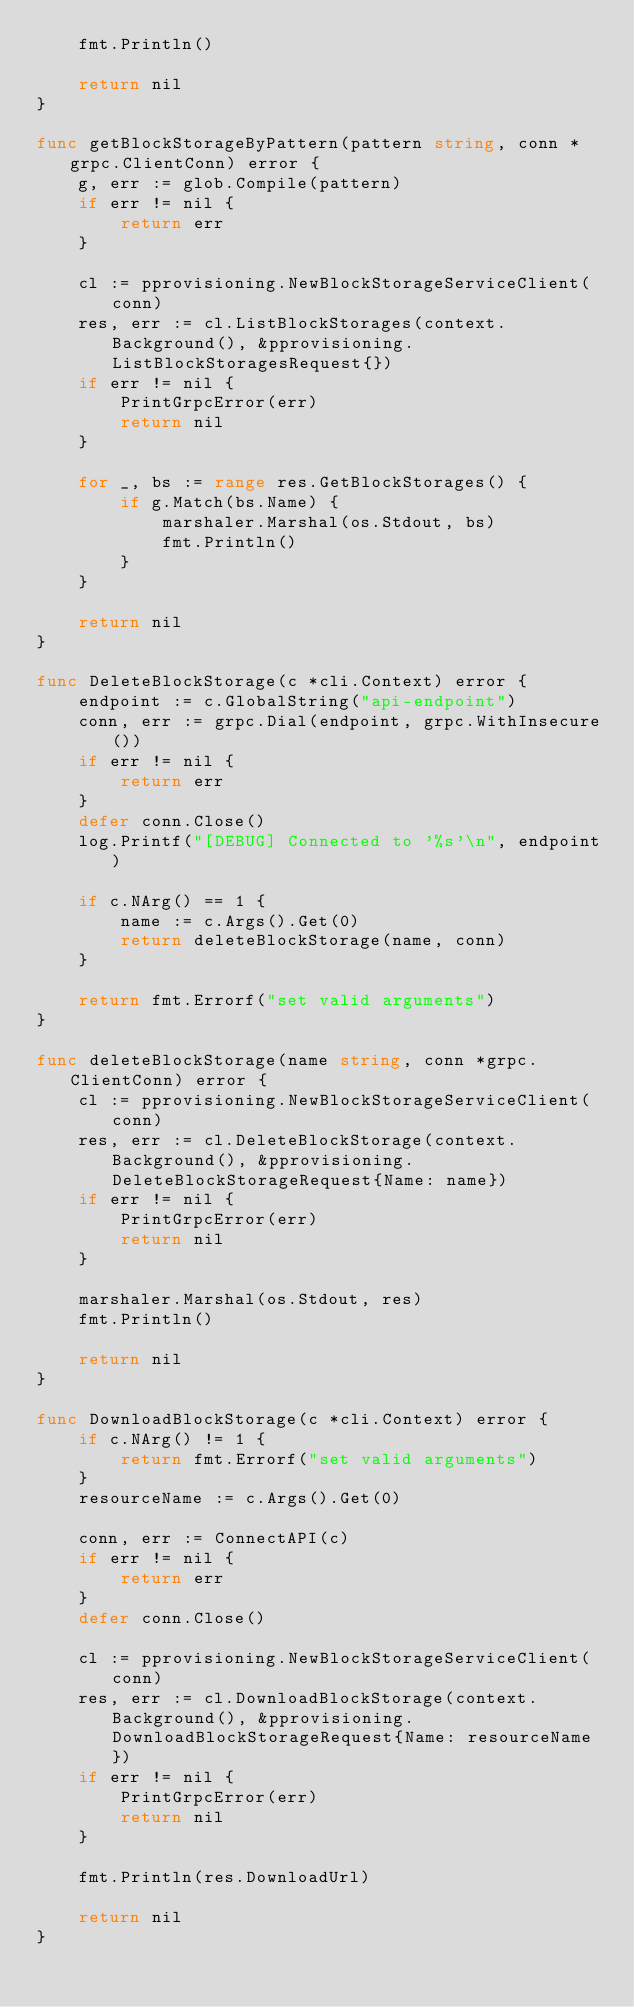<code> <loc_0><loc_0><loc_500><loc_500><_Go_>	fmt.Println()

	return nil
}

func getBlockStorageByPattern(pattern string, conn *grpc.ClientConn) error {
	g, err := glob.Compile(pattern)
	if err != nil {
		return err
	}

	cl := pprovisioning.NewBlockStorageServiceClient(conn)
	res, err := cl.ListBlockStorages(context.Background(), &pprovisioning.ListBlockStoragesRequest{})
	if err != nil {
		PrintGrpcError(err)
		return nil
	}

	for _, bs := range res.GetBlockStorages() {
		if g.Match(bs.Name) {
			marshaler.Marshal(os.Stdout, bs)
			fmt.Println()
		}
	}

	return nil
}

func DeleteBlockStorage(c *cli.Context) error {
	endpoint := c.GlobalString("api-endpoint")
	conn, err := grpc.Dial(endpoint, grpc.WithInsecure())
	if err != nil {
		return err
	}
	defer conn.Close()
	log.Printf("[DEBUG] Connected to '%s'\n", endpoint)

	if c.NArg() == 1 {
		name := c.Args().Get(0)
		return deleteBlockStorage(name, conn)
	}

	return fmt.Errorf("set valid arguments")
}

func deleteBlockStorage(name string, conn *grpc.ClientConn) error {
	cl := pprovisioning.NewBlockStorageServiceClient(conn)
	res, err := cl.DeleteBlockStorage(context.Background(), &pprovisioning.DeleteBlockStorageRequest{Name: name})
	if err != nil {
		PrintGrpcError(err)
		return nil
	}

	marshaler.Marshal(os.Stdout, res)
	fmt.Println()

	return nil
}

func DownloadBlockStorage(c *cli.Context) error {
	if c.NArg() != 1 {
		return fmt.Errorf("set valid arguments")
	}
	resourceName := c.Args().Get(0)

	conn, err := ConnectAPI(c)
	if err != nil {
		return err
	}
	defer conn.Close()

	cl := pprovisioning.NewBlockStorageServiceClient(conn)
	res, err := cl.DownloadBlockStorage(context.Background(), &pprovisioning.DownloadBlockStorageRequest{Name: resourceName})
	if err != nil {
		PrintGrpcError(err)
		return nil
	}

	fmt.Println(res.DownloadUrl)

	return nil
}
</code> 